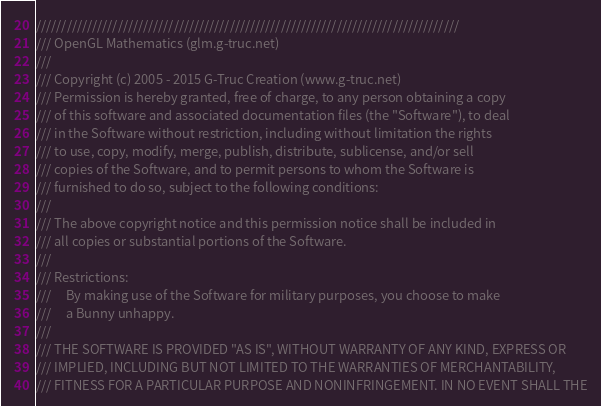<code> <loc_0><loc_0><loc_500><loc_500><_C++_>///////////////////////////////////////////////////////////////////////////////////
/// OpenGL Mathematics (glm.g-truc.net)
///
/// Copyright (c) 2005 - 2015 G-Truc Creation (www.g-truc.net)
/// Permission is hereby granted, free of charge, to any person obtaining a copy
/// of this software and associated documentation files (the "Software"), to deal
/// in the Software without restriction, including without limitation the rights
/// to use, copy, modify, merge, publish, distribute, sublicense, and/or sell
/// copies of the Software, and to permit persons to whom the Software is
/// furnished to do so, subject to the following conditions:
/// 
/// The above copyright notice and this permission notice shall be included in
/// all copies or substantial portions of the Software.
/// 
/// Restrictions:
///		By making use of the Software for military purposes, you choose to make
///		a Bunny unhappy.
/// 
/// THE SOFTWARE IS PROVIDED "AS IS", WITHOUT WARRANTY OF ANY KIND, EXPRESS OR
/// IMPLIED, INCLUDING BUT NOT LIMITED TO THE WARRANTIES OF MERCHANTABILITY,
/// FITNESS FOR A PARTICULAR PURPOSE AND NONINFRINGEMENT. IN NO EVENT SHALL THE</code> 